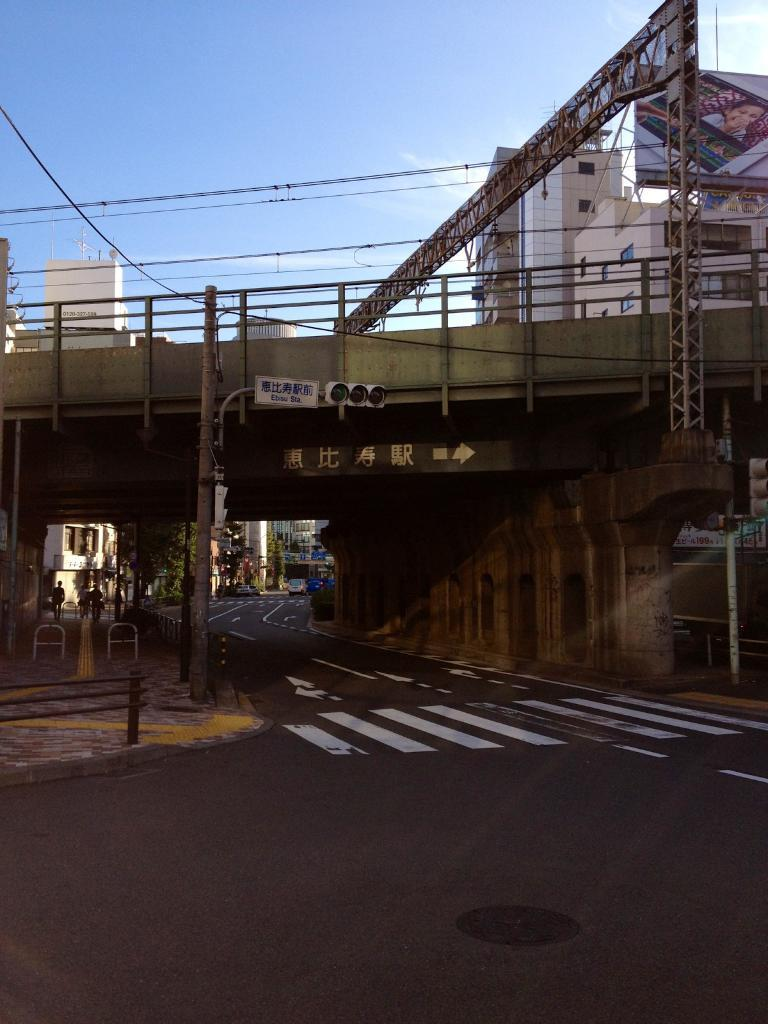What is the main feature in the foreground of the image? There is a bridge in the front of the image. What type of pathway can be seen in the image? There is a road in the image. What structures are visible at the top of the image? There are buildings visible at the top of the image. What type of advertisement is present in the image? There is a hoarding in the image. What is visible in the background of the image? The sky is visible at the top of the image. What type of science experiment can be seen in the image? There is no science experiment present in the image. What type of basket is hanging from the bridge in the image? There is no basket present in the image. 